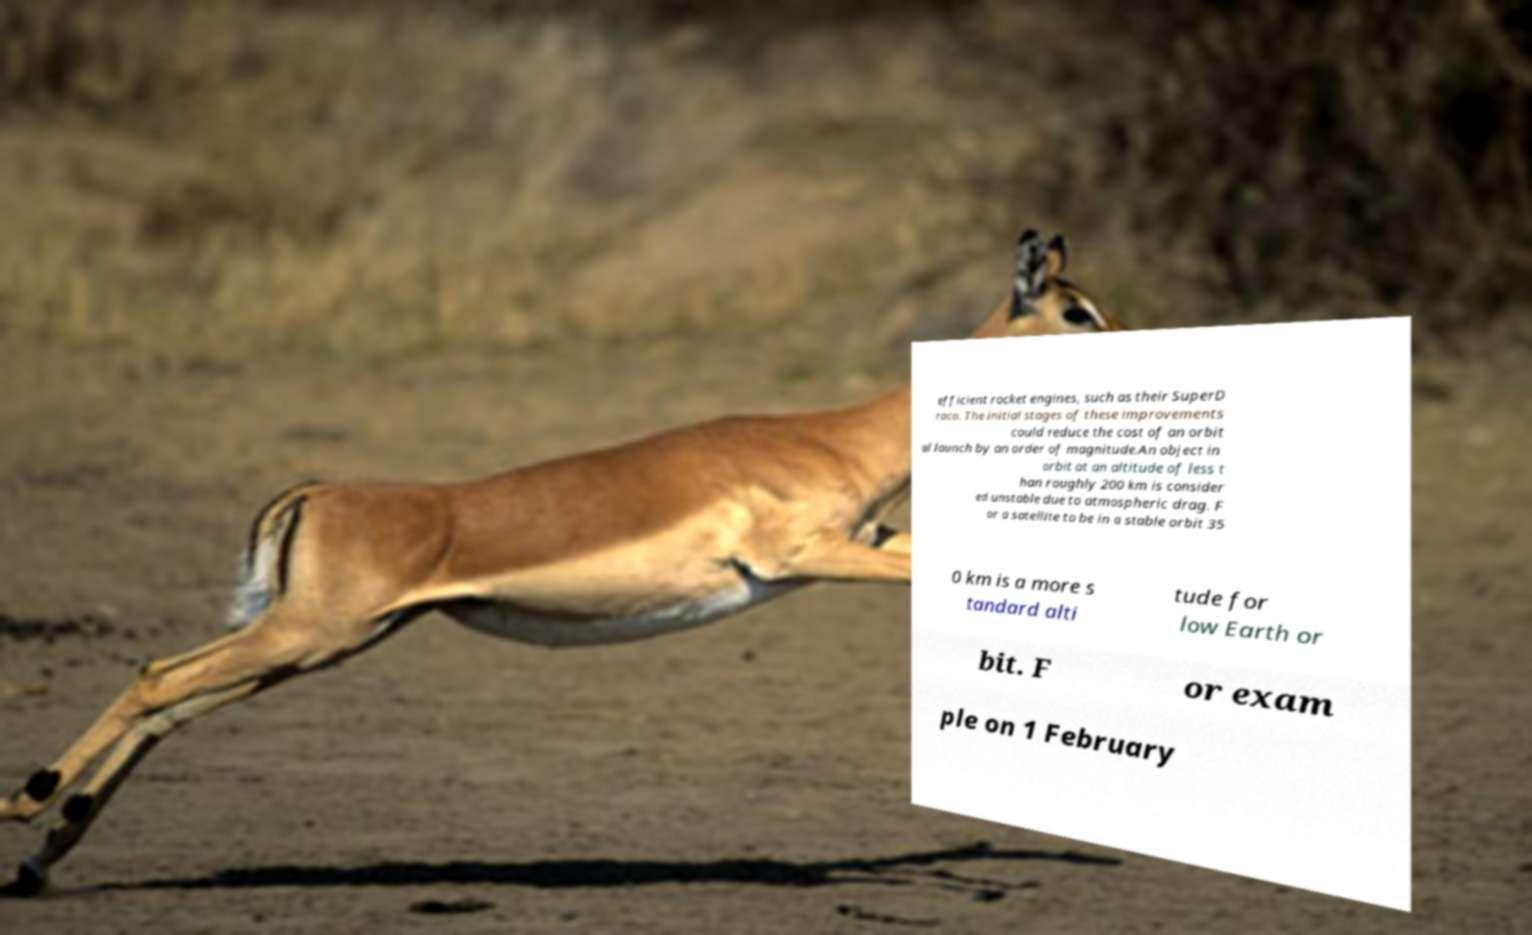Can you read and provide the text displayed in the image?This photo seems to have some interesting text. Can you extract and type it out for me? efficient rocket engines, such as their SuperD raco. The initial stages of these improvements could reduce the cost of an orbit al launch by an order of magnitude.An object in orbit at an altitude of less t han roughly 200 km is consider ed unstable due to atmospheric drag. F or a satellite to be in a stable orbit 35 0 km is a more s tandard alti tude for low Earth or bit. F or exam ple on 1 February 